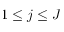<formula> <loc_0><loc_0><loc_500><loc_500>1 \leq j \leq J</formula> 